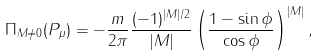Convert formula to latex. <formula><loc_0><loc_0><loc_500><loc_500>\Pi _ { M \neq 0 } ( P _ { \mu } ) = - \frac { m } { 2 \pi } \frac { ( - 1 ) ^ { | M | / 2 } } { | M | } \left ( \frac { 1 - \sin \phi } { \cos \phi } \right ) ^ { | M | } ,</formula> 